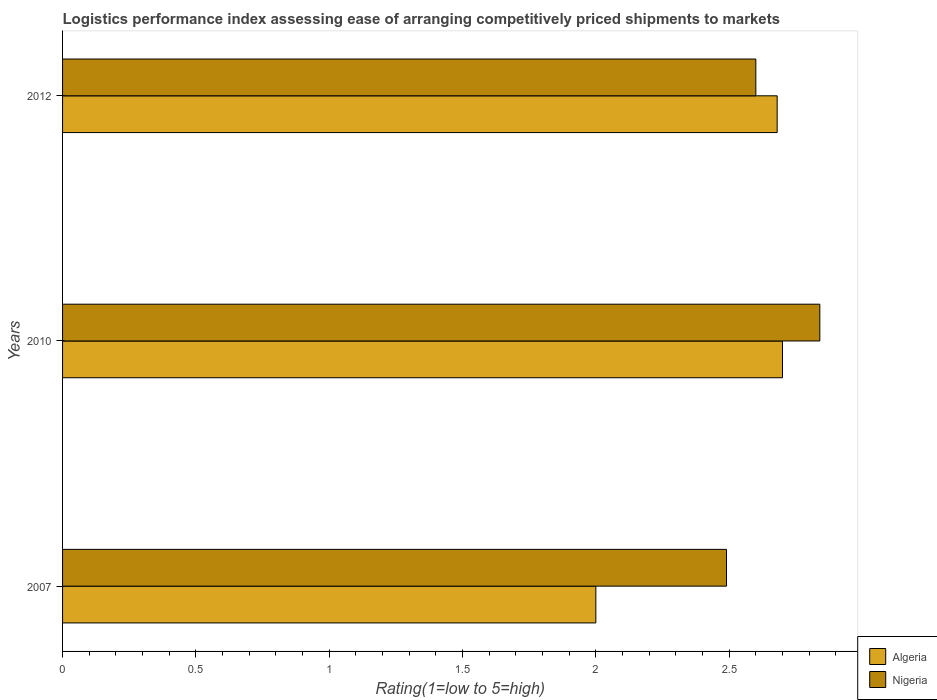How many groups of bars are there?
Offer a very short reply. 3. Are the number of bars per tick equal to the number of legend labels?
Give a very brief answer. Yes. Are the number of bars on each tick of the Y-axis equal?
Offer a very short reply. Yes. How many bars are there on the 2nd tick from the top?
Ensure brevity in your answer.  2. What is the Logistic performance index in Algeria in 2010?
Your answer should be compact. 2.7. Across all years, what is the maximum Logistic performance index in Algeria?
Provide a succinct answer. 2.7. What is the total Logistic performance index in Nigeria in the graph?
Offer a terse response. 7.93. What is the difference between the Logistic performance index in Nigeria in 2007 and that in 2012?
Make the answer very short. -0.11. What is the difference between the Logistic performance index in Algeria in 2007 and the Logistic performance index in Nigeria in 2012?
Your response must be concise. -0.6. What is the average Logistic performance index in Algeria per year?
Keep it short and to the point. 2.46. In the year 2012, what is the difference between the Logistic performance index in Nigeria and Logistic performance index in Algeria?
Offer a very short reply. -0.08. In how many years, is the Logistic performance index in Nigeria greater than 1.7 ?
Provide a short and direct response. 3. What is the ratio of the Logistic performance index in Nigeria in 2007 to that in 2012?
Provide a short and direct response. 0.96. Is the Logistic performance index in Nigeria in 2010 less than that in 2012?
Offer a terse response. No. Is the difference between the Logistic performance index in Nigeria in 2007 and 2012 greater than the difference between the Logistic performance index in Algeria in 2007 and 2012?
Your response must be concise. Yes. What is the difference between the highest and the second highest Logistic performance index in Algeria?
Keep it short and to the point. 0.02. What is the difference between the highest and the lowest Logistic performance index in Algeria?
Offer a terse response. 0.7. In how many years, is the Logistic performance index in Algeria greater than the average Logistic performance index in Algeria taken over all years?
Your answer should be compact. 2. What does the 1st bar from the top in 2012 represents?
Keep it short and to the point. Nigeria. What does the 2nd bar from the bottom in 2007 represents?
Keep it short and to the point. Nigeria. Are all the bars in the graph horizontal?
Offer a very short reply. Yes. What is the difference between two consecutive major ticks on the X-axis?
Your answer should be very brief. 0.5. Does the graph contain grids?
Provide a succinct answer. No. What is the title of the graph?
Your answer should be very brief. Logistics performance index assessing ease of arranging competitively priced shipments to markets. Does "Algeria" appear as one of the legend labels in the graph?
Ensure brevity in your answer.  Yes. What is the label or title of the X-axis?
Offer a terse response. Rating(1=low to 5=high). What is the label or title of the Y-axis?
Offer a terse response. Years. What is the Rating(1=low to 5=high) of Nigeria in 2007?
Ensure brevity in your answer.  2.49. What is the Rating(1=low to 5=high) in Algeria in 2010?
Your answer should be compact. 2.7. What is the Rating(1=low to 5=high) of Nigeria in 2010?
Make the answer very short. 2.84. What is the Rating(1=low to 5=high) of Algeria in 2012?
Offer a very short reply. 2.68. What is the Rating(1=low to 5=high) of Nigeria in 2012?
Provide a short and direct response. 2.6. Across all years, what is the maximum Rating(1=low to 5=high) in Algeria?
Your answer should be compact. 2.7. Across all years, what is the maximum Rating(1=low to 5=high) of Nigeria?
Your answer should be compact. 2.84. Across all years, what is the minimum Rating(1=low to 5=high) of Algeria?
Give a very brief answer. 2. Across all years, what is the minimum Rating(1=low to 5=high) of Nigeria?
Provide a succinct answer. 2.49. What is the total Rating(1=low to 5=high) of Algeria in the graph?
Your answer should be very brief. 7.38. What is the total Rating(1=low to 5=high) of Nigeria in the graph?
Your response must be concise. 7.93. What is the difference between the Rating(1=low to 5=high) of Nigeria in 2007 and that in 2010?
Provide a short and direct response. -0.35. What is the difference between the Rating(1=low to 5=high) in Algeria in 2007 and that in 2012?
Ensure brevity in your answer.  -0.68. What is the difference between the Rating(1=low to 5=high) in Nigeria in 2007 and that in 2012?
Provide a succinct answer. -0.11. What is the difference between the Rating(1=low to 5=high) in Nigeria in 2010 and that in 2012?
Make the answer very short. 0.24. What is the difference between the Rating(1=low to 5=high) of Algeria in 2007 and the Rating(1=low to 5=high) of Nigeria in 2010?
Provide a succinct answer. -0.84. What is the difference between the Rating(1=low to 5=high) in Algeria in 2010 and the Rating(1=low to 5=high) in Nigeria in 2012?
Offer a very short reply. 0.1. What is the average Rating(1=low to 5=high) in Algeria per year?
Your response must be concise. 2.46. What is the average Rating(1=low to 5=high) in Nigeria per year?
Keep it short and to the point. 2.64. In the year 2007, what is the difference between the Rating(1=low to 5=high) of Algeria and Rating(1=low to 5=high) of Nigeria?
Keep it short and to the point. -0.49. In the year 2010, what is the difference between the Rating(1=low to 5=high) of Algeria and Rating(1=low to 5=high) of Nigeria?
Provide a short and direct response. -0.14. What is the ratio of the Rating(1=low to 5=high) in Algeria in 2007 to that in 2010?
Offer a terse response. 0.74. What is the ratio of the Rating(1=low to 5=high) of Nigeria in 2007 to that in 2010?
Offer a very short reply. 0.88. What is the ratio of the Rating(1=low to 5=high) in Algeria in 2007 to that in 2012?
Ensure brevity in your answer.  0.75. What is the ratio of the Rating(1=low to 5=high) of Nigeria in 2007 to that in 2012?
Your answer should be compact. 0.96. What is the ratio of the Rating(1=low to 5=high) of Algeria in 2010 to that in 2012?
Offer a terse response. 1.01. What is the ratio of the Rating(1=low to 5=high) of Nigeria in 2010 to that in 2012?
Your response must be concise. 1.09. What is the difference between the highest and the second highest Rating(1=low to 5=high) in Algeria?
Keep it short and to the point. 0.02. What is the difference between the highest and the second highest Rating(1=low to 5=high) in Nigeria?
Offer a very short reply. 0.24. 